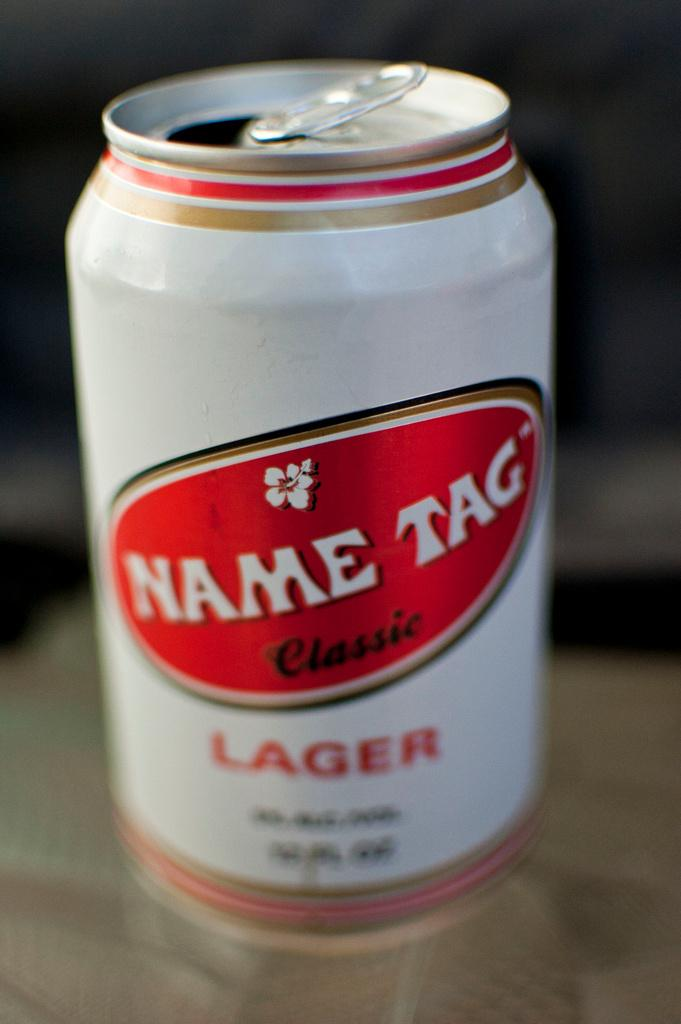<image>
Share a concise interpretation of the image provided. An open can of Name Tag Classic Lager sits on the table. 